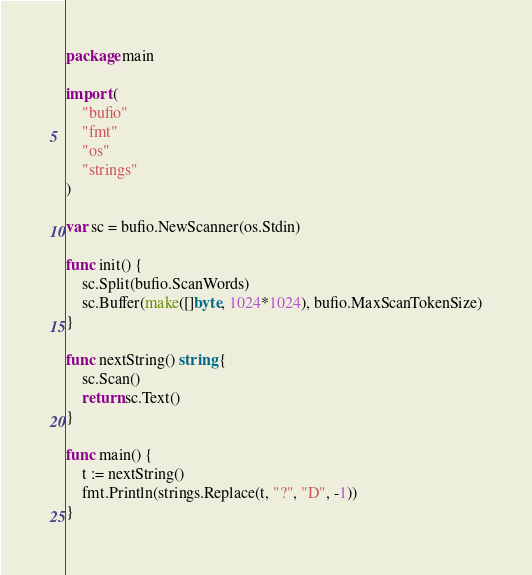Convert code to text. <code><loc_0><loc_0><loc_500><loc_500><_Go_>package main

import (
	"bufio"
	"fmt"
	"os"
	"strings"
)

var sc = bufio.NewScanner(os.Stdin)

func init() {
	sc.Split(bufio.ScanWords)
	sc.Buffer(make([]byte, 1024*1024), bufio.MaxScanTokenSize)
}

func nextString() string {
	sc.Scan()
	return sc.Text()
}

func main() {
	t := nextString()
	fmt.Println(strings.Replace(t, "?", "D", -1))
}</code> 